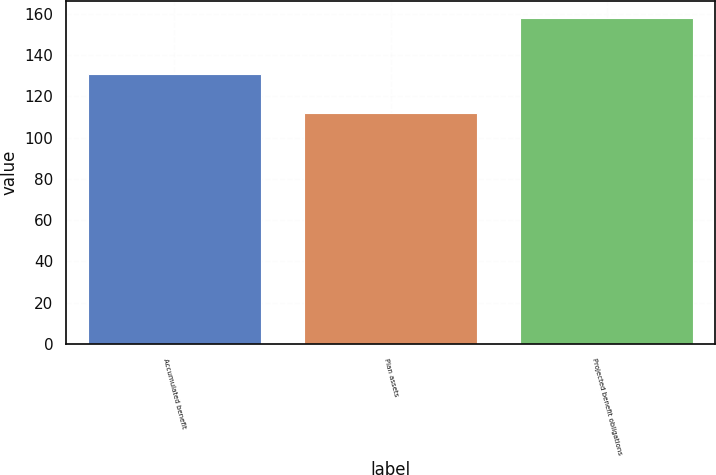Convert chart. <chart><loc_0><loc_0><loc_500><loc_500><bar_chart><fcel>Accumulated benefit<fcel>Plan assets<fcel>Projected benefit obligations<nl><fcel>130.7<fcel>112.1<fcel>158.1<nl></chart> 